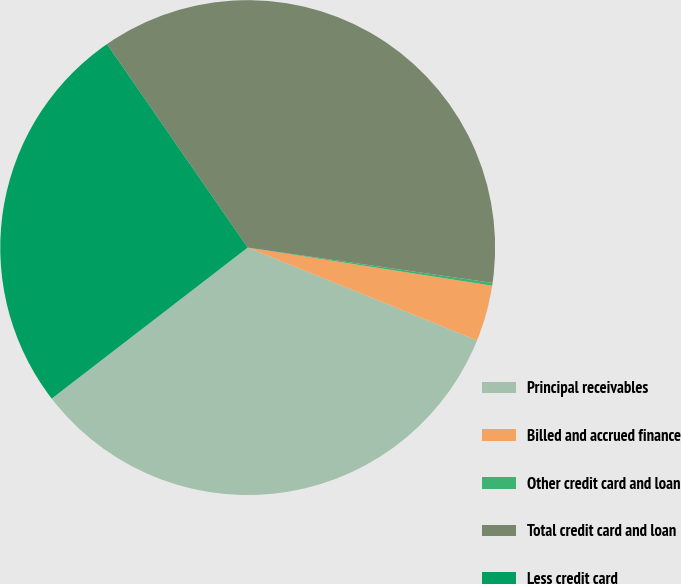<chart> <loc_0><loc_0><loc_500><loc_500><pie_chart><fcel>Principal receivables<fcel>Billed and accrued finance<fcel>Other credit card and loan<fcel>Total credit card and loan<fcel>Less credit card<nl><fcel>33.43%<fcel>3.66%<fcel>0.18%<fcel>36.91%<fcel>25.82%<nl></chart> 